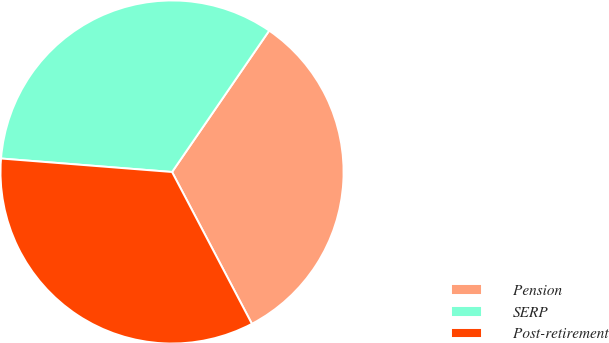Convert chart to OTSL. <chart><loc_0><loc_0><loc_500><loc_500><pie_chart><fcel>Pension<fcel>SERP<fcel>Post-retirement<nl><fcel>32.71%<fcel>33.33%<fcel>33.96%<nl></chart> 